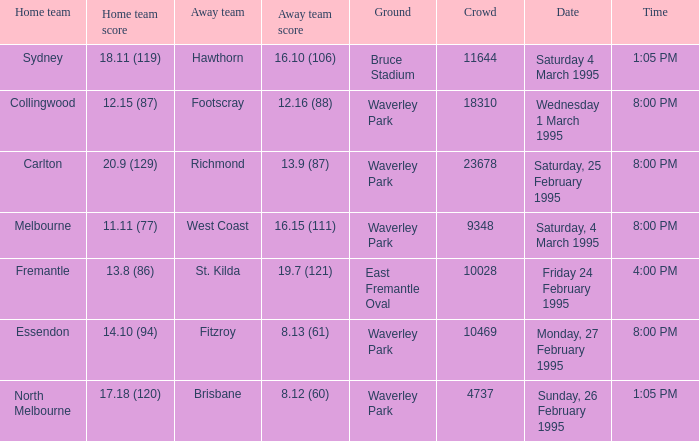Name the total number of grounds for essendon 1.0. 